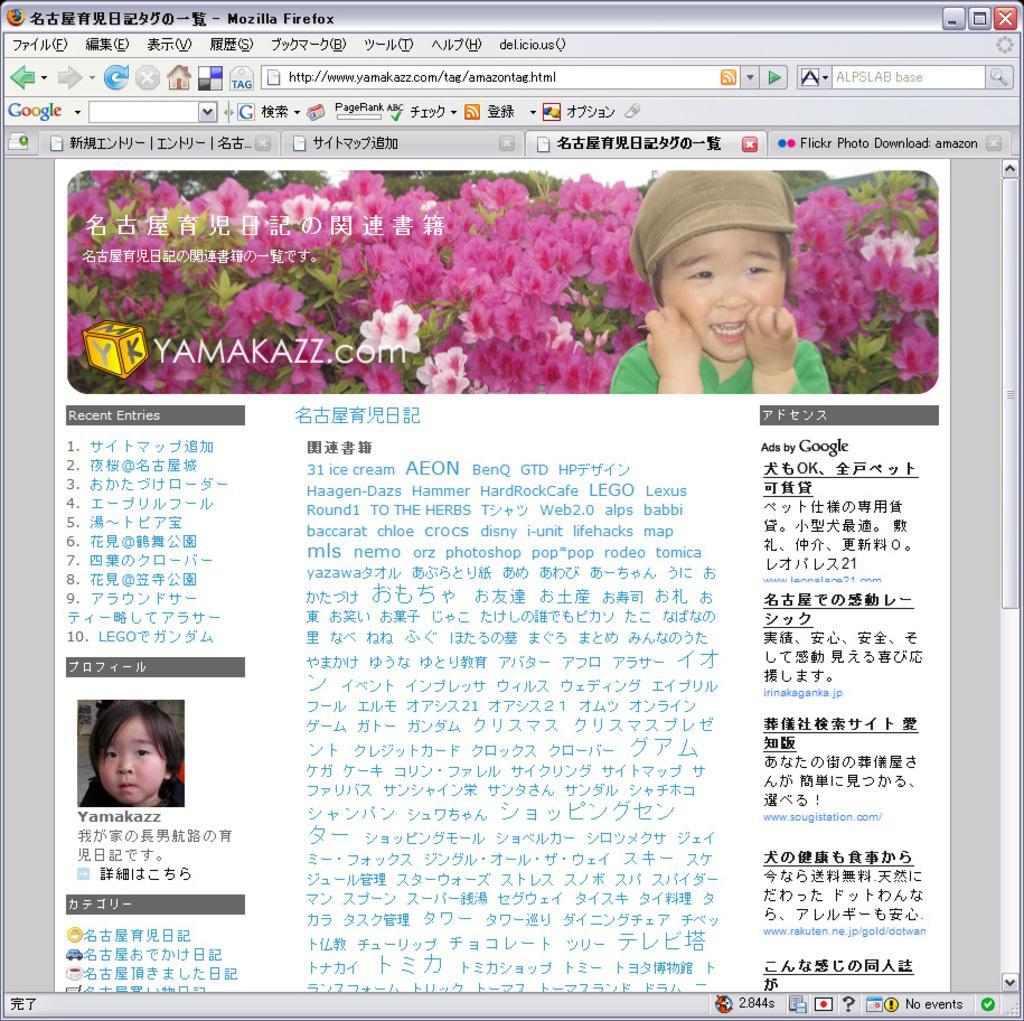In one or two sentences, can you explain what this image depicts? This image consists of a screenshot. In which we can see a kid and flowers in pink color along with plants. At the bottom, there is text. 